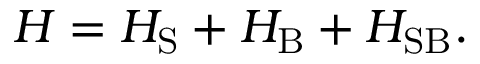Convert formula to latex. <formula><loc_0><loc_0><loc_500><loc_500>H = H _ { S } + H _ { B } + H _ { S B } .</formula> 